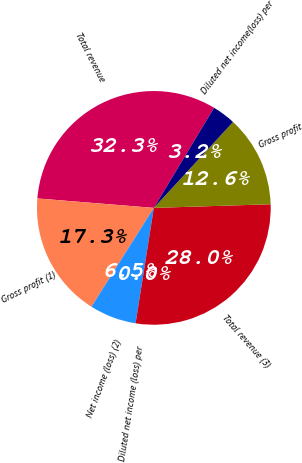Convert chart. <chart><loc_0><loc_0><loc_500><loc_500><pie_chart><fcel>Total revenue<fcel>Gross profit (1)<fcel>Net income (loss) (2)<fcel>Diluted net income (loss) per<fcel>Total revenue (3)<fcel>Gross profit<fcel>Diluted net income(loss) per<nl><fcel>32.34%<fcel>17.33%<fcel>6.47%<fcel>0.0%<fcel>27.99%<fcel>12.65%<fcel>3.23%<nl></chart> 